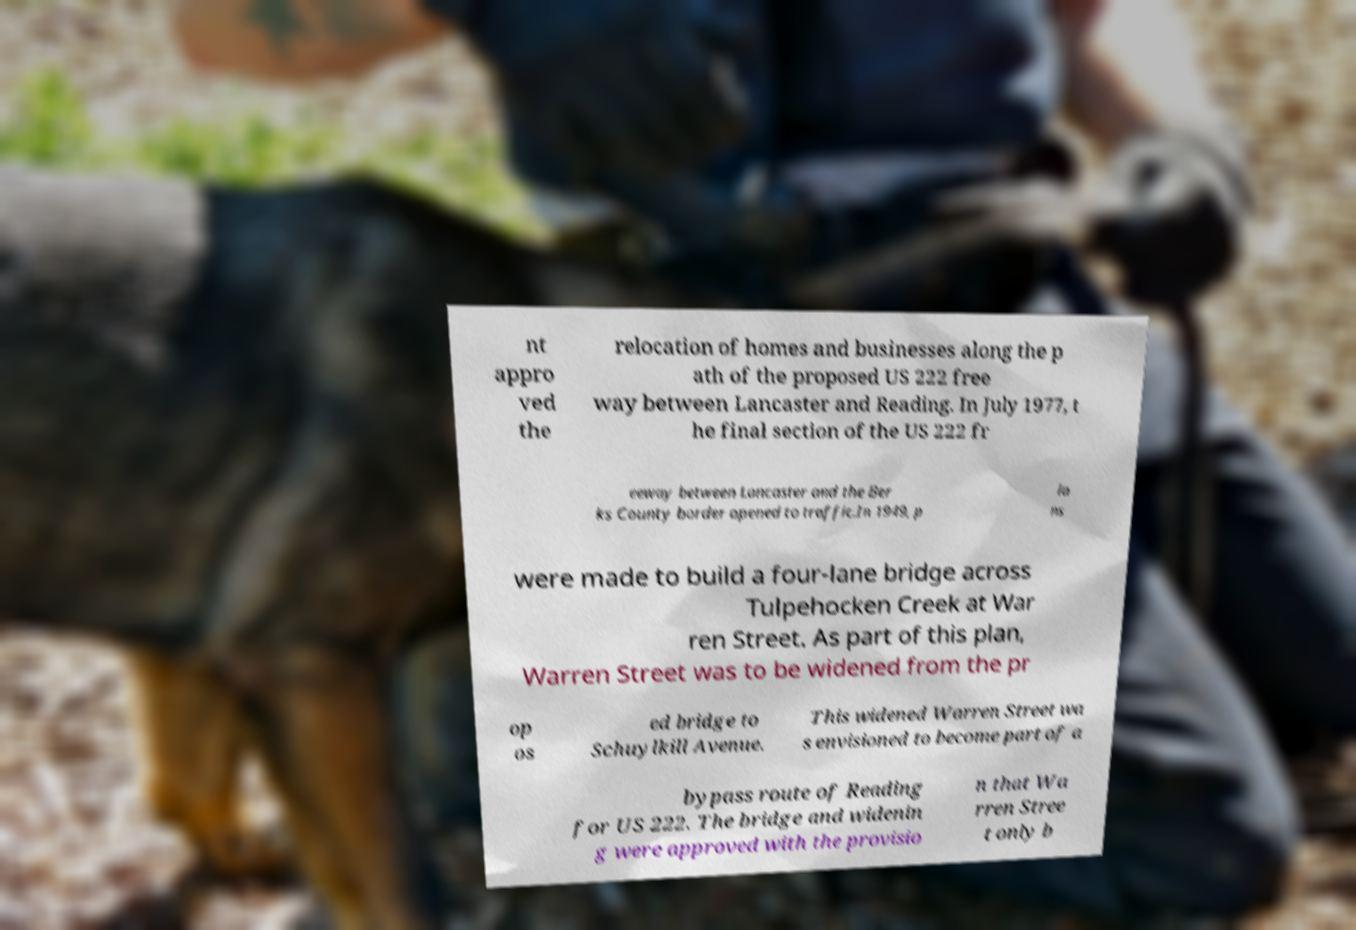Please identify and transcribe the text found in this image. nt appro ved the relocation of homes and businesses along the p ath of the proposed US 222 free way between Lancaster and Reading. In July 1977, t he final section of the US 222 fr eeway between Lancaster and the Ber ks County border opened to traffic.In 1949, p la ns were made to build a four-lane bridge across Tulpehocken Creek at War ren Street. As part of this plan, Warren Street was to be widened from the pr op os ed bridge to Schuylkill Avenue. This widened Warren Street wa s envisioned to become part of a bypass route of Reading for US 222. The bridge and widenin g were approved with the provisio n that Wa rren Stree t only b 